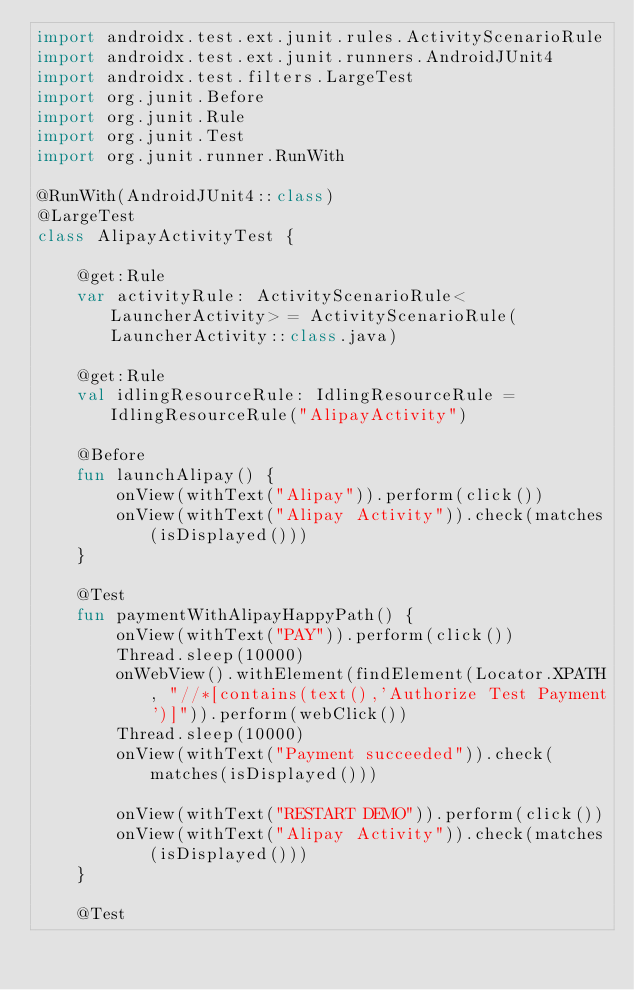Convert code to text. <code><loc_0><loc_0><loc_500><loc_500><_Kotlin_>import androidx.test.ext.junit.rules.ActivityScenarioRule
import androidx.test.ext.junit.runners.AndroidJUnit4
import androidx.test.filters.LargeTest
import org.junit.Before
import org.junit.Rule
import org.junit.Test
import org.junit.runner.RunWith

@RunWith(AndroidJUnit4::class)
@LargeTest
class AlipayActivityTest {

    @get:Rule
    var activityRule: ActivityScenarioRule<LauncherActivity> = ActivityScenarioRule(LauncherActivity::class.java)

    @get:Rule
    val idlingResourceRule: IdlingResourceRule = IdlingResourceRule("AlipayActivity")

    @Before
    fun launchAlipay() {
        onView(withText("Alipay")).perform(click())
        onView(withText("Alipay Activity")).check(matches(isDisplayed()))
    }

    @Test
    fun paymentWithAlipayHappyPath() {
        onView(withText("PAY")).perform(click())
        Thread.sleep(10000)
        onWebView().withElement(findElement(Locator.XPATH, "//*[contains(text(),'Authorize Test Payment')]")).perform(webClick())
        Thread.sleep(10000)
        onView(withText("Payment succeeded")).check(matches(isDisplayed()))

        onView(withText("RESTART DEMO")).perform(click())
        onView(withText("Alipay Activity")).check(matches(isDisplayed()))
    }

    @Test</code> 